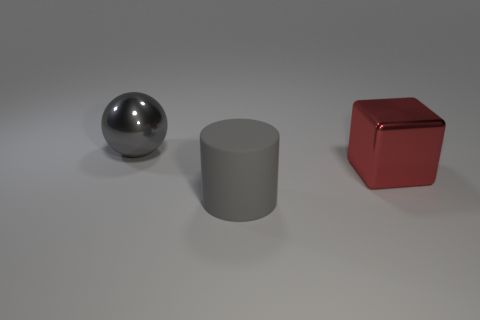Add 2 rubber objects. How many objects exist? 5 Subtract all spheres. How many objects are left? 2 Subtract all large purple matte things. Subtract all large cylinders. How many objects are left? 2 Add 3 big cylinders. How many big cylinders are left? 4 Add 3 metal cubes. How many metal cubes exist? 4 Subtract 0 blue blocks. How many objects are left? 3 Subtract all cyan cylinders. Subtract all green balls. How many cylinders are left? 1 